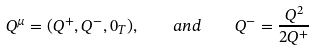Convert formula to latex. <formula><loc_0><loc_0><loc_500><loc_500>Q ^ { \mu } = ( Q ^ { + } , Q ^ { - } , 0 _ { T } ) , \quad a n d \quad Q ^ { - } = \frac { Q ^ { 2 } } { 2 Q ^ { + } } \\</formula> 